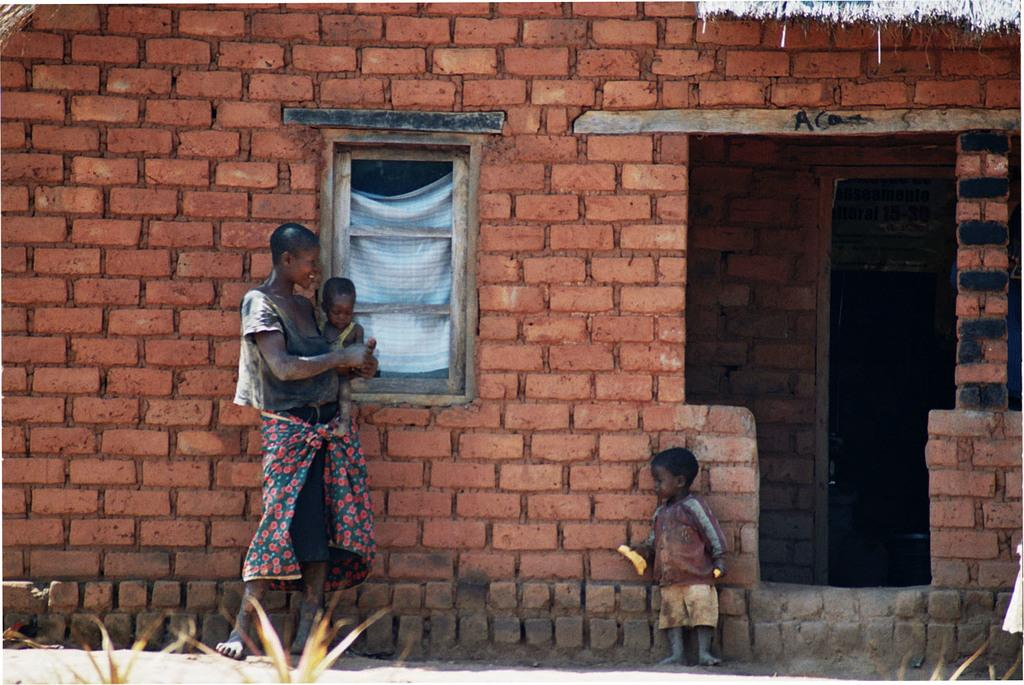Who is present in the image? There is a woman and two kids in the image. What can be seen at the bottom of the image? There are plants at the bottom of the image. What is visible in the background of the image? There is a house in the background of the image. What architectural feature is in the middle of the image? There is a window in the middle of the image. What type of hearing aid is the woman wearing in the image? There is no hearing aid visible on the woman in the image. Who is the woman's partner in the image? There is no mention of a partner in the image; it only shows a woman and two kids. 